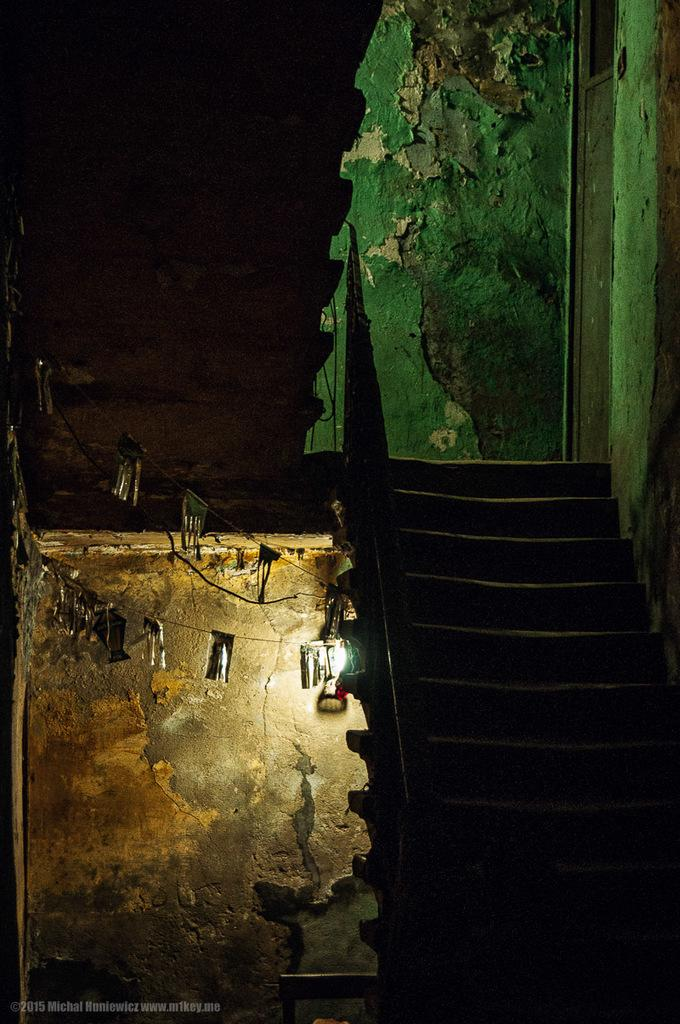What type of architectural feature is present in the image? There are steps in the image. What else can be seen in the image besides the steps? There is a wall and a light in the image. How would you describe the overall lighting in the image? The background of the image is dark. What type of rice is being offered on the steps in the image? There is no rice present in the image, and the steps are not being used for offering anything. 